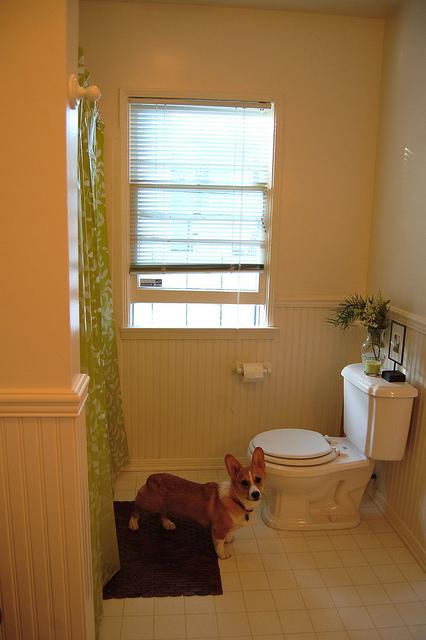How many animals are in this photo?
Be succinct. 1. What room is this?
Write a very short answer. Bathroom. Who is in the bathroom?
Keep it brief. Dog. Is this bathroom for the dog?
Quick response, please. No. Could this dog escape through the window?
Give a very brief answer. Yes. 